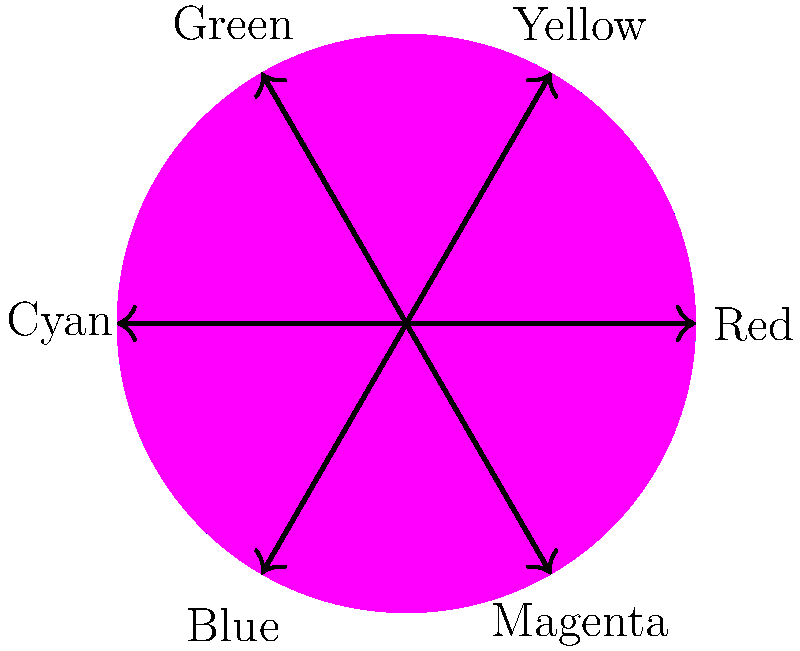In plant photography, which color combination would create the strongest visual contrast according to the color wheel? To determine the strongest visual contrast in plant photography using the color wheel:

1. Understand the color wheel: The color wheel is divided into primary colors (red, blue, yellow) and secondary colors (green, orange, purple).

2. Identify complementary colors: Complementary colors are directly opposite each other on the color wheel. They create the strongest contrast when used together.

3. Analyze the color wheel:
   - Red is opposite Green
   - Blue is opposite Orange
   - Yellow is opposite Purple

4. Apply to plant photography:
   - Red flowers with green foliage
   - Blue flowers against orange/autumn leaves
   - Yellow flowers with purple/lavender plants

5. Consider the strongest contrast: Among these, red and green are the most common in nature and create a striking visual impact in plant photography.

Therefore, the combination of red and green would create the strongest visual contrast according to the color wheel in plant photography.
Answer: Red and green 